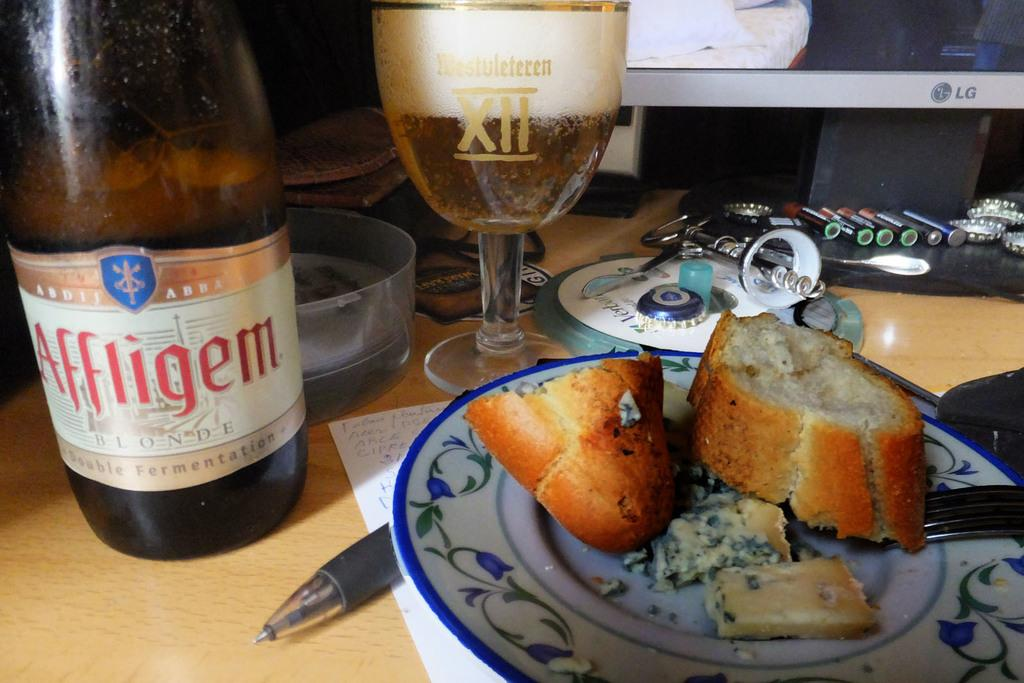<image>
Offer a succinct explanation of the picture presented. A bottle, labelled Affligem Blonde, sits next to a plate of bread. 